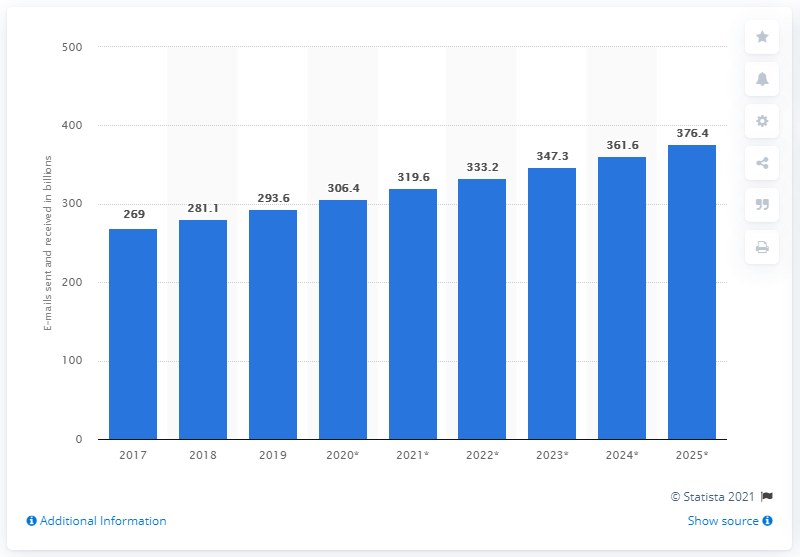Give some essential details in this illustration. Since 2017, the number of e-mails sent and received globally has increased. In 2020, an average of 306.4 emails were sent and received per day. 